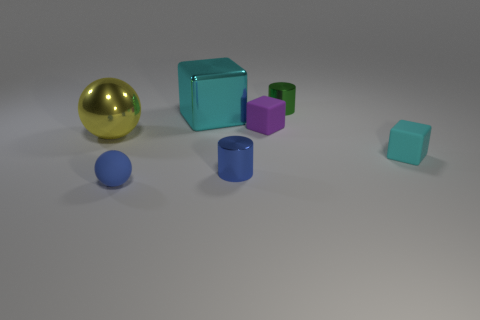Describe the texture visible on the surface of the smallest sphere. The smallest sphere in the image has a smooth texture with no discernible bumps or irregularities. Its surface is uniformly colored, which accentuates its polished appearance. 